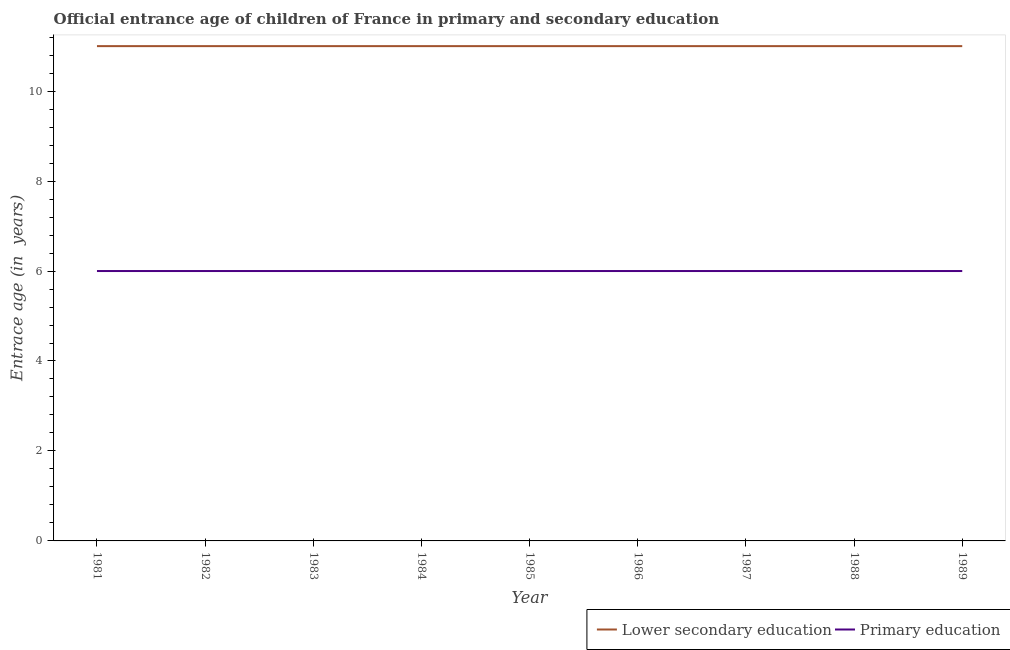How many different coloured lines are there?
Provide a short and direct response. 2. Across all years, what is the minimum entrance age of chiildren in primary education?
Keep it short and to the point. 6. In which year was the entrance age of chiildren in primary education maximum?
Provide a succinct answer. 1981. In which year was the entrance age of children in lower secondary education minimum?
Give a very brief answer. 1981. What is the total entrance age of children in lower secondary education in the graph?
Offer a very short reply. 99. What is the difference between the entrance age of children in lower secondary education in 1981 and the entrance age of chiildren in primary education in 1984?
Offer a very short reply. 5. In the year 1983, what is the difference between the entrance age of children in lower secondary education and entrance age of chiildren in primary education?
Ensure brevity in your answer.  5. Is the difference between the entrance age of children in lower secondary education in 1981 and 1985 greater than the difference between the entrance age of chiildren in primary education in 1981 and 1985?
Provide a short and direct response. No. What is the difference between the highest and the second highest entrance age of children in lower secondary education?
Keep it short and to the point. 0. In how many years, is the entrance age of children in lower secondary education greater than the average entrance age of children in lower secondary education taken over all years?
Make the answer very short. 0. Is the sum of the entrance age of children in lower secondary education in 1984 and 1985 greater than the maximum entrance age of chiildren in primary education across all years?
Provide a short and direct response. Yes. Is the entrance age of children in lower secondary education strictly greater than the entrance age of chiildren in primary education over the years?
Your response must be concise. Yes. How many lines are there?
Keep it short and to the point. 2. What is the difference between two consecutive major ticks on the Y-axis?
Your response must be concise. 2. Are the values on the major ticks of Y-axis written in scientific E-notation?
Your answer should be very brief. No. Does the graph contain grids?
Provide a succinct answer. No. How many legend labels are there?
Provide a succinct answer. 2. What is the title of the graph?
Your response must be concise. Official entrance age of children of France in primary and secondary education. What is the label or title of the X-axis?
Provide a short and direct response. Year. What is the label or title of the Y-axis?
Ensure brevity in your answer.  Entrace age (in  years). What is the Entrace age (in  years) in Primary education in 1981?
Your answer should be very brief. 6. What is the Entrace age (in  years) in Lower secondary education in 1984?
Give a very brief answer. 11. What is the Entrace age (in  years) in Primary education in 1984?
Provide a short and direct response. 6. What is the Entrace age (in  years) in Lower secondary education in 1985?
Offer a terse response. 11. What is the Entrace age (in  years) of Lower secondary education in 1986?
Offer a terse response. 11. What is the Entrace age (in  years) of Lower secondary education in 1987?
Offer a terse response. 11. What is the Entrace age (in  years) of Primary education in 1987?
Give a very brief answer. 6. What is the Entrace age (in  years) in Lower secondary education in 1988?
Make the answer very short. 11. What is the Entrace age (in  years) in Primary education in 1988?
Offer a very short reply. 6. What is the Entrace age (in  years) of Lower secondary education in 1989?
Provide a short and direct response. 11. Across all years, what is the maximum Entrace age (in  years) of Lower secondary education?
Your answer should be very brief. 11. Across all years, what is the maximum Entrace age (in  years) in Primary education?
Your response must be concise. 6. Across all years, what is the minimum Entrace age (in  years) in Lower secondary education?
Offer a very short reply. 11. What is the total Entrace age (in  years) in Lower secondary education in the graph?
Ensure brevity in your answer.  99. What is the difference between the Entrace age (in  years) of Primary education in 1981 and that in 1983?
Your response must be concise. 0. What is the difference between the Entrace age (in  years) of Lower secondary education in 1981 and that in 1984?
Keep it short and to the point. 0. What is the difference between the Entrace age (in  years) of Primary education in 1981 and that in 1984?
Give a very brief answer. 0. What is the difference between the Entrace age (in  years) in Lower secondary education in 1981 and that in 1986?
Keep it short and to the point. 0. What is the difference between the Entrace age (in  years) in Primary education in 1981 and that in 1987?
Offer a terse response. 0. What is the difference between the Entrace age (in  years) of Lower secondary education in 1981 and that in 1988?
Offer a terse response. 0. What is the difference between the Entrace age (in  years) of Lower secondary education in 1981 and that in 1989?
Offer a terse response. 0. What is the difference between the Entrace age (in  years) of Primary education in 1981 and that in 1989?
Give a very brief answer. 0. What is the difference between the Entrace age (in  years) in Lower secondary education in 1982 and that in 1983?
Provide a succinct answer. 0. What is the difference between the Entrace age (in  years) in Primary education in 1982 and that in 1984?
Offer a very short reply. 0. What is the difference between the Entrace age (in  years) in Lower secondary education in 1982 and that in 1985?
Provide a short and direct response. 0. What is the difference between the Entrace age (in  years) of Primary education in 1982 and that in 1986?
Offer a terse response. 0. What is the difference between the Entrace age (in  years) in Lower secondary education in 1983 and that in 1985?
Give a very brief answer. 0. What is the difference between the Entrace age (in  years) in Lower secondary education in 1983 and that in 1986?
Your answer should be very brief. 0. What is the difference between the Entrace age (in  years) of Primary education in 1983 and that in 1987?
Your answer should be very brief. 0. What is the difference between the Entrace age (in  years) in Lower secondary education in 1983 and that in 1988?
Keep it short and to the point. 0. What is the difference between the Entrace age (in  years) in Primary education in 1983 and that in 1989?
Provide a short and direct response. 0. What is the difference between the Entrace age (in  years) of Primary education in 1984 and that in 1985?
Your answer should be very brief. 0. What is the difference between the Entrace age (in  years) of Lower secondary education in 1984 and that in 1986?
Your answer should be compact. 0. What is the difference between the Entrace age (in  years) in Lower secondary education in 1984 and that in 1987?
Give a very brief answer. 0. What is the difference between the Entrace age (in  years) of Primary education in 1984 and that in 1987?
Ensure brevity in your answer.  0. What is the difference between the Entrace age (in  years) of Primary education in 1984 and that in 1989?
Your answer should be compact. 0. What is the difference between the Entrace age (in  years) in Lower secondary education in 1985 and that in 1986?
Offer a terse response. 0. What is the difference between the Entrace age (in  years) in Primary education in 1985 and that in 1986?
Your answer should be very brief. 0. What is the difference between the Entrace age (in  years) of Primary education in 1985 and that in 1987?
Your answer should be very brief. 0. What is the difference between the Entrace age (in  years) of Primary education in 1985 and that in 1988?
Your response must be concise. 0. What is the difference between the Entrace age (in  years) of Primary education in 1985 and that in 1989?
Your response must be concise. 0. What is the difference between the Entrace age (in  years) of Lower secondary education in 1986 and that in 1987?
Make the answer very short. 0. What is the difference between the Entrace age (in  years) of Lower secondary education in 1986 and that in 1988?
Your answer should be very brief. 0. What is the difference between the Entrace age (in  years) in Primary education in 1986 and that in 1988?
Your answer should be very brief. 0. What is the difference between the Entrace age (in  years) in Lower secondary education in 1987 and that in 1988?
Make the answer very short. 0. What is the difference between the Entrace age (in  years) of Primary education in 1987 and that in 1988?
Give a very brief answer. 0. What is the difference between the Entrace age (in  years) of Lower secondary education in 1987 and that in 1989?
Ensure brevity in your answer.  0. What is the difference between the Entrace age (in  years) of Lower secondary education in 1988 and that in 1989?
Provide a short and direct response. 0. What is the difference between the Entrace age (in  years) of Primary education in 1988 and that in 1989?
Your answer should be very brief. 0. What is the difference between the Entrace age (in  years) of Lower secondary education in 1981 and the Entrace age (in  years) of Primary education in 1983?
Provide a succinct answer. 5. What is the difference between the Entrace age (in  years) of Lower secondary education in 1981 and the Entrace age (in  years) of Primary education in 1984?
Offer a very short reply. 5. What is the difference between the Entrace age (in  years) of Lower secondary education in 1981 and the Entrace age (in  years) of Primary education in 1985?
Keep it short and to the point. 5. What is the difference between the Entrace age (in  years) of Lower secondary education in 1981 and the Entrace age (in  years) of Primary education in 1986?
Provide a succinct answer. 5. What is the difference between the Entrace age (in  years) in Lower secondary education in 1981 and the Entrace age (in  years) in Primary education in 1988?
Provide a short and direct response. 5. What is the difference between the Entrace age (in  years) of Lower secondary education in 1981 and the Entrace age (in  years) of Primary education in 1989?
Make the answer very short. 5. What is the difference between the Entrace age (in  years) of Lower secondary education in 1982 and the Entrace age (in  years) of Primary education in 1983?
Keep it short and to the point. 5. What is the difference between the Entrace age (in  years) of Lower secondary education in 1982 and the Entrace age (in  years) of Primary education in 1984?
Offer a terse response. 5. What is the difference between the Entrace age (in  years) in Lower secondary education in 1983 and the Entrace age (in  years) in Primary education in 1986?
Provide a succinct answer. 5. What is the difference between the Entrace age (in  years) in Lower secondary education in 1983 and the Entrace age (in  years) in Primary education in 1987?
Provide a succinct answer. 5. What is the difference between the Entrace age (in  years) of Lower secondary education in 1983 and the Entrace age (in  years) of Primary education in 1988?
Provide a short and direct response. 5. What is the difference between the Entrace age (in  years) in Lower secondary education in 1983 and the Entrace age (in  years) in Primary education in 1989?
Offer a very short reply. 5. What is the difference between the Entrace age (in  years) in Lower secondary education in 1984 and the Entrace age (in  years) in Primary education in 1985?
Ensure brevity in your answer.  5. What is the difference between the Entrace age (in  years) of Lower secondary education in 1984 and the Entrace age (in  years) of Primary education in 1987?
Provide a short and direct response. 5. What is the difference between the Entrace age (in  years) of Lower secondary education in 1984 and the Entrace age (in  years) of Primary education in 1988?
Offer a very short reply. 5. What is the difference between the Entrace age (in  years) in Lower secondary education in 1985 and the Entrace age (in  years) in Primary education in 1986?
Ensure brevity in your answer.  5. What is the difference between the Entrace age (in  years) of Lower secondary education in 1985 and the Entrace age (in  years) of Primary education in 1988?
Your answer should be compact. 5. What is the difference between the Entrace age (in  years) in Lower secondary education in 1985 and the Entrace age (in  years) in Primary education in 1989?
Provide a succinct answer. 5. What is the difference between the Entrace age (in  years) in Lower secondary education in 1986 and the Entrace age (in  years) in Primary education in 1989?
Your answer should be compact. 5. What is the difference between the Entrace age (in  years) in Lower secondary education in 1987 and the Entrace age (in  years) in Primary education in 1988?
Ensure brevity in your answer.  5. In the year 1981, what is the difference between the Entrace age (in  years) of Lower secondary education and Entrace age (in  years) of Primary education?
Your answer should be compact. 5. In the year 1983, what is the difference between the Entrace age (in  years) in Lower secondary education and Entrace age (in  years) in Primary education?
Provide a short and direct response. 5. In the year 1984, what is the difference between the Entrace age (in  years) in Lower secondary education and Entrace age (in  years) in Primary education?
Your answer should be very brief. 5. In the year 1988, what is the difference between the Entrace age (in  years) in Lower secondary education and Entrace age (in  years) in Primary education?
Ensure brevity in your answer.  5. What is the ratio of the Entrace age (in  years) of Primary education in 1981 to that in 1982?
Your response must be concise. 1. What is the ratio of the Entrace age (in  years) of Primary education in 1981 to that in 1983?
Offer a terse response. 1. What is the ratio of the Entrace age (in  years) in Lower secondary education in 1981 to that in 1985?
Your answer should be compact. 1. What is the ratio of the Entrace age (in  years) in Primary education in 1981 to that in 1985?
Your answer should be very brief. 1. What is the ratio of the Entrace age (in  years) in Lower secondary education in 1981 to that in 1987?
Ensure brevity in your answer.  1. What is the ratio of the Entrace age (in  years) in Primary education in 1981 to that in 1987?
Offer a terse response. 1. What is the ratio of the Entrace age (in  years) in Primary education in 1981 to that in 1988?
Ensure brevity in your answer.  1. What is the ratio of the Entrace age (in  years) in Lower secondary education in 1981 to that in 1989?
Offer a terse response. 1. What is the ratio of the Entrace age (in  years) in Primary education in 1981 to that in 1989?
Keep it short and to the point. 1. What is the ratio of the Entrace age (in  years) in Primary education in 1982 to that in 1983?
Provide a succinct answer. 1. What is the ratio of the Entrace age (in  years) of Primary education in 1982 to that in 1984?
Your answer should be compact. 1. What is the ratio of the Entrace age (in  years) of Lower secondary education in 1982 to that in 1986?
Provide a succinct answer. 1. What is the ratio of the Entrace age (in  years) of Primary education in 1982 to that in 1986?
Your answer should be compact. 1. What is the ratio of the Entrace age (in  years) of Lower secondary education in 1982 to that in 1987?
Your answer should be compact. 1. What is the ratio of the Entrace age (in  years) in Primary education in 1982 to that in 1987?
Make the answer very short. 1. What is the ratio of the Entrace age (in  years) in Primary education in 1982 to that in 1988?
Provide a succinct answer. 1. What is the ratio of the Entrace age (in  years) of Lower secondary education in 1982 to that in 1989?
Offer a terse response. 1. What is the ratio of the Entrace age (in  years) of Primary education in 1982 to that in 1989?
Your answer should be compact. 1. What is the ratio of the Entrace age (in  years) of Lower secondary education in 1983 to that in 1984?
Your response must be concise. 1. What is the ratio of the Entrace age (in  years) of Primary education in 1983 to that in 1984?
Your answer should be very brief. 1. What is the ratio of the Entrace age (in  years) in Primary education in 1983 to that in 1985?
Make the answer very short. 1. What is the ratio of the Entrace age (in  years) in Lower secondary education in 1983 to that in 1987?
Your answer should be very brief. 1. What is the ratio of the Entrace age (in  years) of Primary education in 1983 to that in 1988?
Your response must be concise. 1. What is the ratio of the Entrace age (in  years) in Primary education in 1983 to that in 1989?
Provide a succinct answer. 1. What is the ratio of the Entrace age (in  years) in Lower secondary education in 1984 to that in 1985?
Provide a succinct answer. 1. What is the ratio of the Entrace age (in  years) in Lower secondary education in 1984 to that in 1986?
Keep it short and to the point. 1. What is the ratio of the Entrace age (in  years) of Primary education in 1984 to that in 1988?
Your answer should be compact. 1. What is the ratio of the Entrace age (in  years) of Primary education in 1985 to that in 1986?
Keep it short and to the point. 1. What is the ratio of the Entrace age (in  years) in Primary education in 1985 to that in 1987?
Give a very brief answer. 1. What is the ratio of the Entrace age (in  years) in Lower secondary education in 1985 to that in 1989?
Your answer should be very brief. 1. What is the ratio of the Entrace age (in  years) in Lower secondary education in 1986 to that in 1988?
Provide a short and direct response. 1. What is the ratio of the Entrace age (in  years) of Primary education in 1986 to that in 1988?
Your response must be concise. 1. What is the ratio of the Entrace age (in  years) of Lower secondary education in 1986 to that in 1989?
Give a very brief answer. 1. What is the ratio of the Entrace age (in  years) in Lower secondary education in 1987 to that in 1989?
Your answer should be very brief. 1. What is the ratio of the Entrace age (in  years) of Primary education in 1987 to that in 1989?
Ensure brevity in your answer.  1. What is the ratio of the Entrace age (in  years) of Lower secondary education in 1988 to that in 1989?
Ensure brevity in your answer.  1. What is the difference between the highest and the second highest Entrace age (in  years) in Lower secondary education?
Offer a terse response. 0. What is the difference between the highest and the second highest Entrace age (in  years) in Primary education?
Keep it short and to the point. 0. What is the difference between the highest and the lowest Entrace age (in  years) in Lower secondary education?
Offer a terse response. 0. What is the difference between the highest and the lowest Entrace age (in  years) of Primary education?
Offer a terse response. 0. 